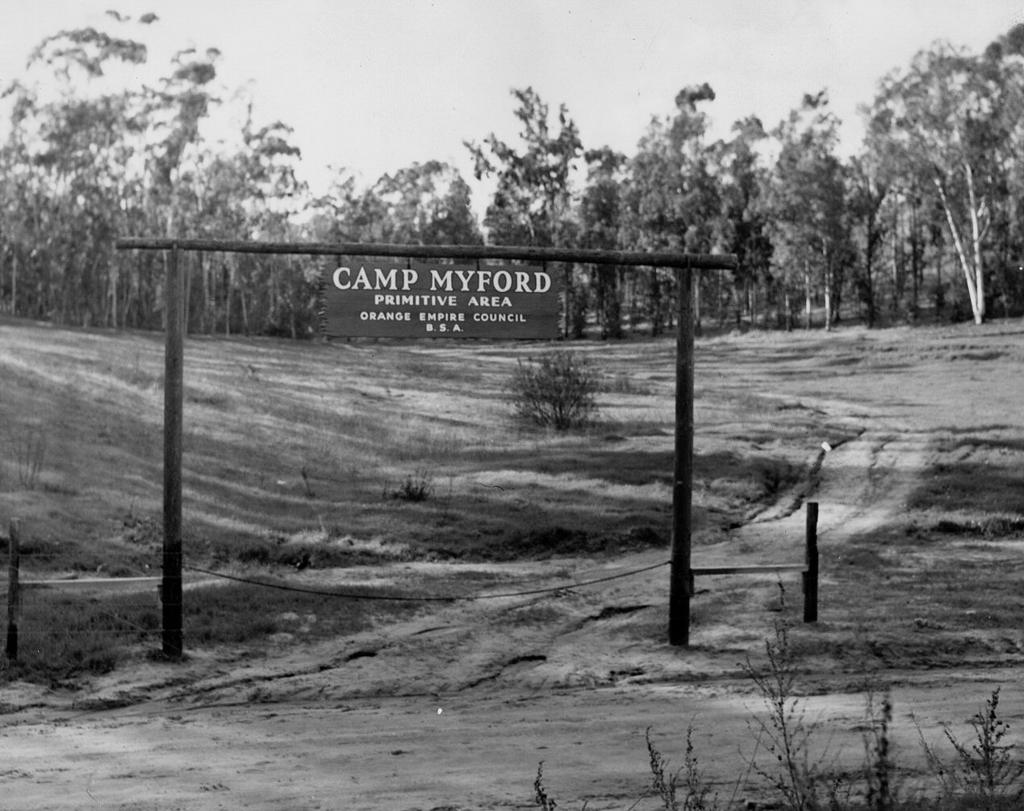What is the primary surface visible in the image? There is a ground in the image. What is present on the ground? There are plants on the ground. What other natural elements can be seen in the image? There are trees in the image. Can you describe the structure made of sticks and a board? Yes, there is a board tied to sticks in the image. What is visible at the top of the image? The sky is visible at the top of the image. What type of credit card is being used to purchase the plants in the image? There is no credit card or purchase activity depicted in the image; it only shows plants on the ground, trees, a board tied to sticks, and the sky. 